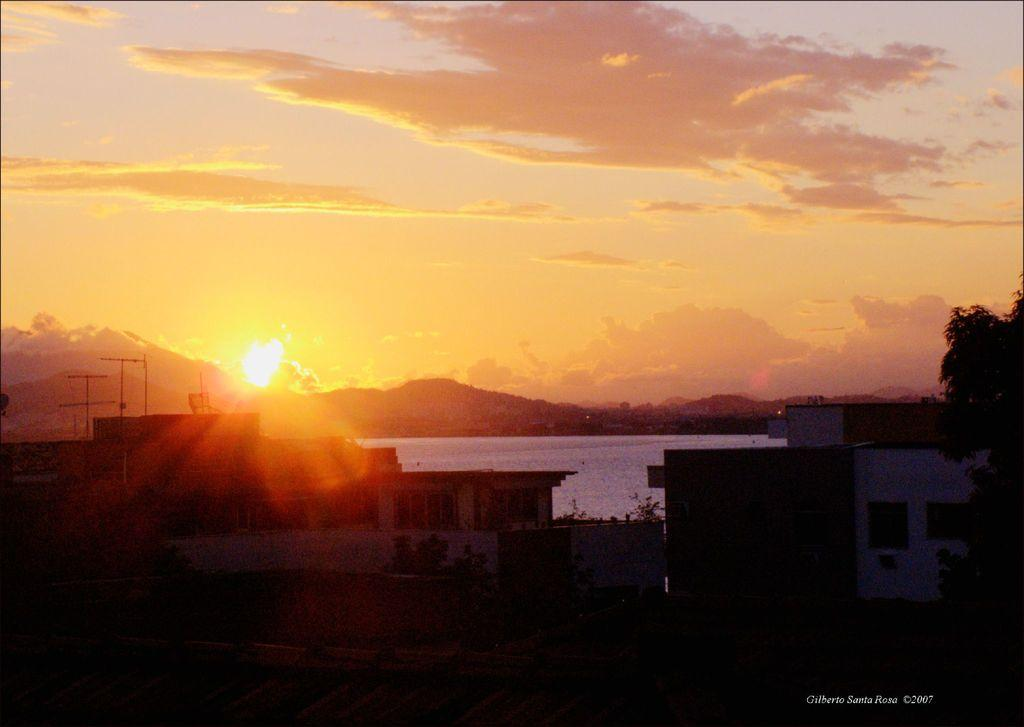What type of structures are visible in the image? There are buildings with windows in the image. What other natural elements can be seen in the image? There are trees and mountains in the image. What is visible in the background of the image? The sky is visible in the background of the image. What can be observed in the sky? Clouds are present in the sky. How does the respect rub against the knife in the image? There is no respect, rubbing, or knife present in the image. 